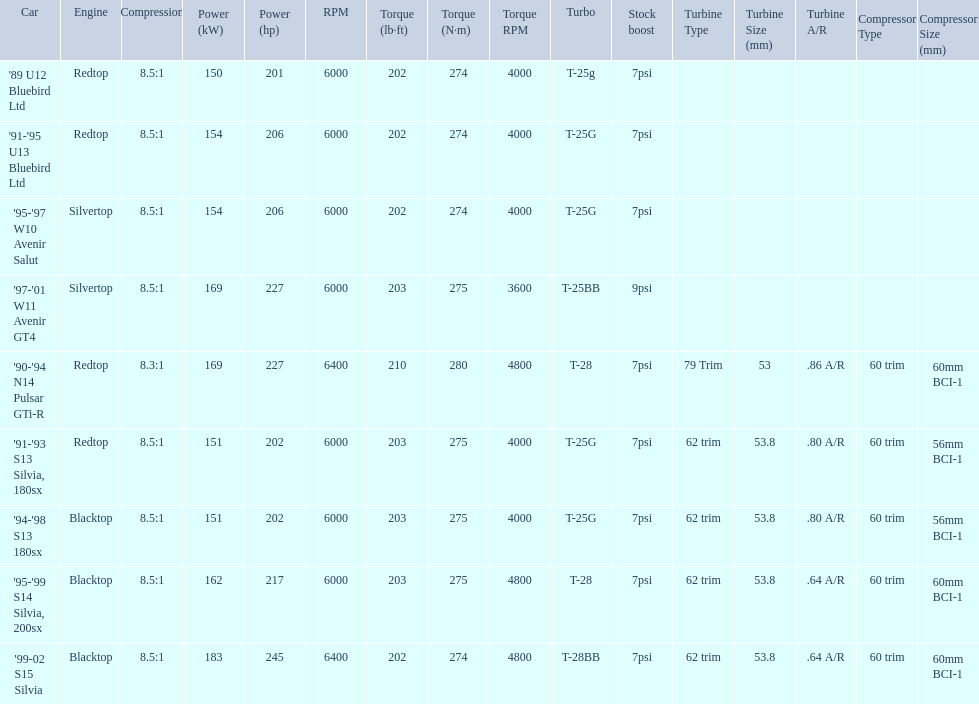What are all the cars? '89 U12 Bluebird Ltd, '91-'95 U13 Bluebird Ltd, '95-'97 W10 Avenir Salut, '97-'01 W11 Avenir GT4, '90-'94 N14 Pulsar GTi-R, '91-'93 S13 Silvia, 180sx, '94-'98 S13 180sx, '95-'99 S14 Silvia, 200sx, '99-02 S15 Silvia. What are their stock boosts? 7psi, 7psi, 7psi, 9psi, 7psi, 7psi, 7psi, 7psi, 7psi. And which car has the highest stock boost? '97-'01 W11 Avenir GT4. 